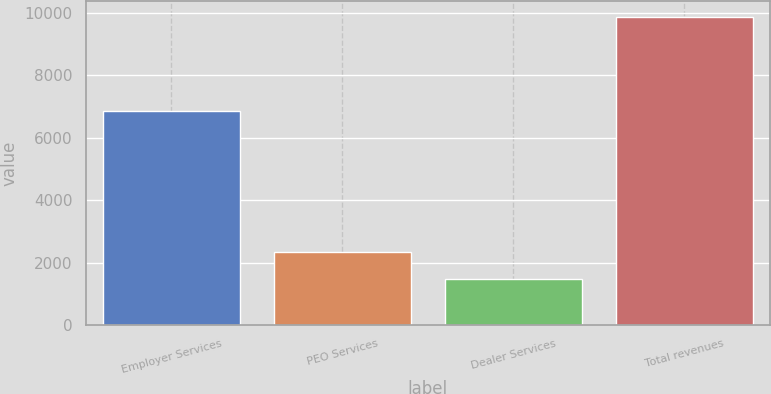Convert chart to OTSL. <chart><loc_0><loc_0><loc_500><loc_500><bar_chart><fcel>Employer Services<fcel>PEO Services<fcel>Dealer Services<fcel>Total revenues<nl><fcel>6861.7<fcel>2332.91<fcel>1494.4<fcel>9879.5<nl></chart> 